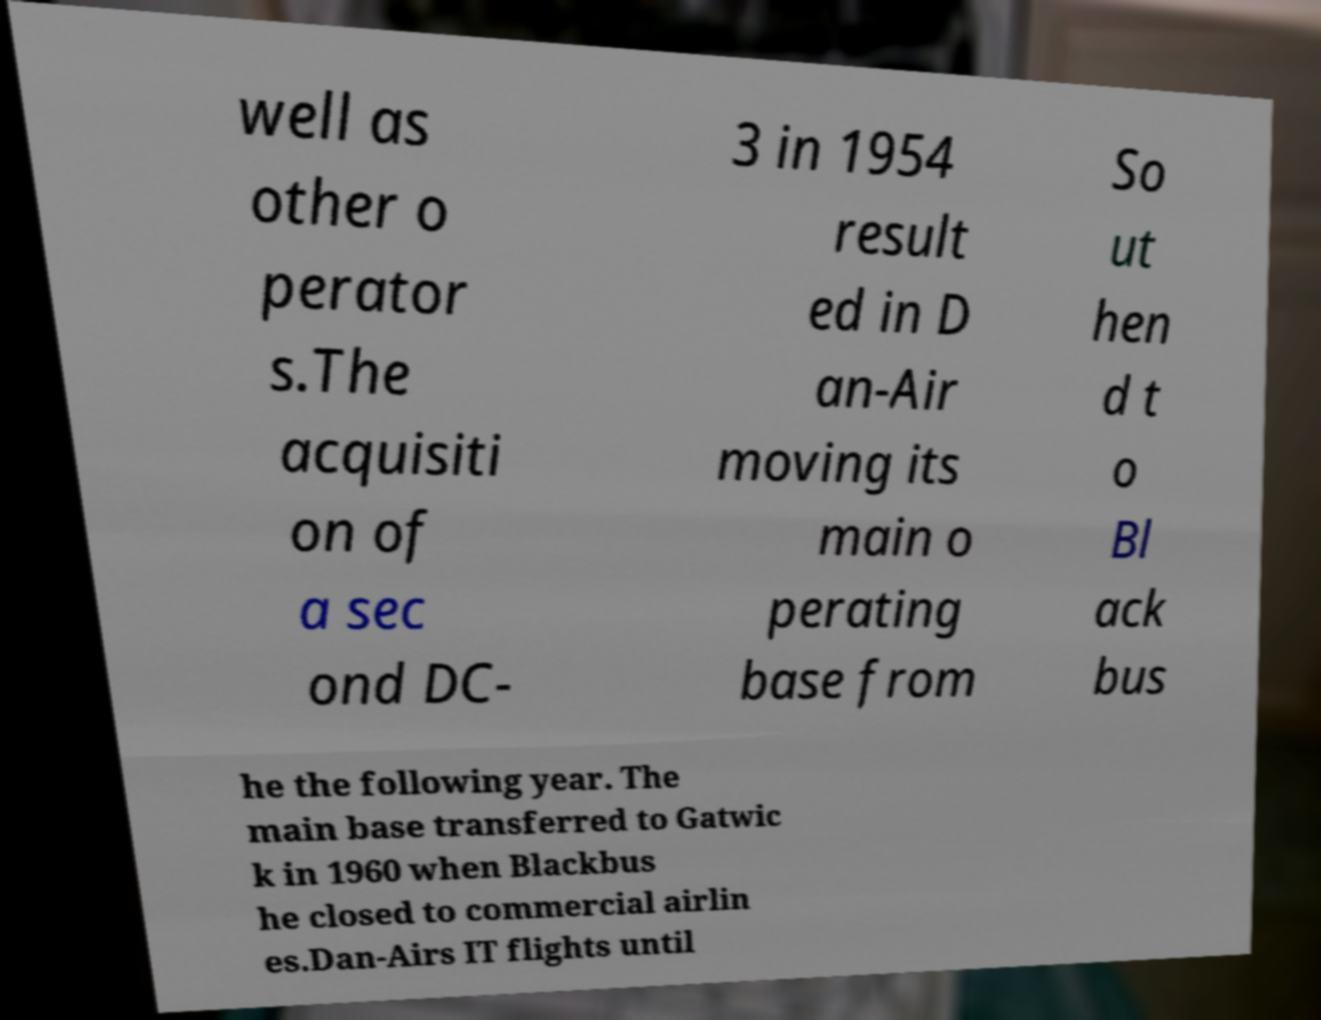Please read and relay the text visible in this image. What does it say? well as other o perator s.The acquisiti on of a sec ond DC- 3 in 1954 result ed in D an-Air moving its main o perating base from So ut hen d t o Bl ack bus he the following year. The main base transferred to Gatwic k in 1960 when Blackbus he closed to commercial airlin es.Dan-Airs IT flights until 